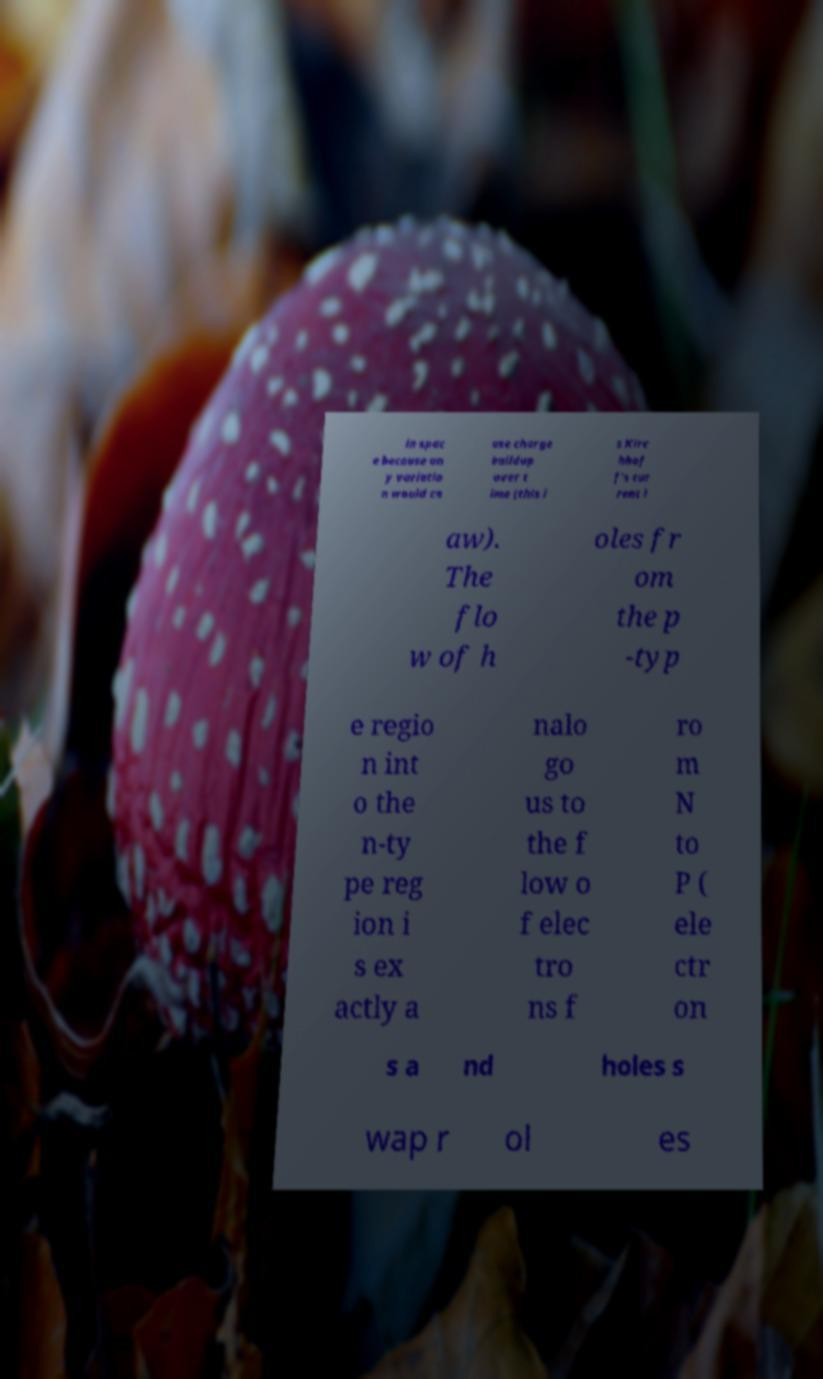I need the written content from this picture converted into text. Can you do that? in spac e because an y variatio n would ca use charge buildup over t ime (this i s Kirc hhof f's cur rent l aw). The flo w of h oles fr om the p -typ e regio n int o the n-ty pe reg ion i s ex actly a nalo go us to the f low o f elec tro ns f ro m N to P ( ele ctr on s a nd holes s wap r ol es 